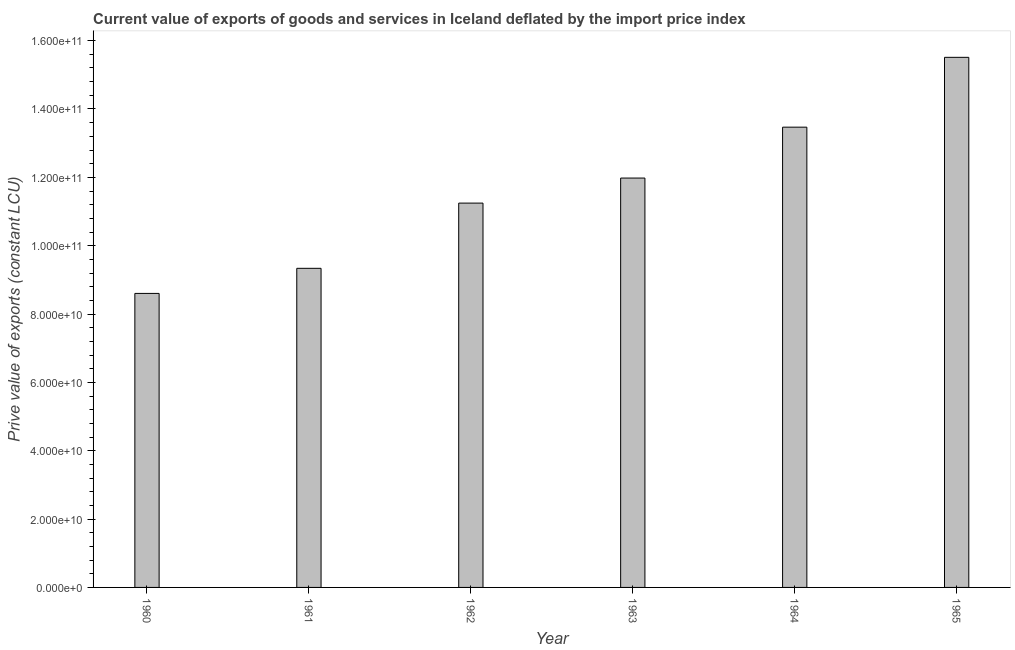What is the title of the graph?
Offer a terse response. Current value of exports of goods and services in Iceland deflated by the import price index. What is the label or title of the Y-axis?
Your answer should be very brief. Prive value of exports (constant LCU). What is the price value of exports in 1962?
Provide a succinct answer. 1.12e+11. Across all years, what is the maximum price value of exports?
Your answer should be very brief. 1.55e+11. Across all years, what is the minimum price value of exports?
Provide a succinct answer. 8.60e+1. In which year was the price value of exports maximum?
Provide a succinct answer. 1965. What is the sum of the price value of exports?
Give a very brief answer. 7.01e+11. What is the difference between the price value of exports in 1963 and 1964?
Keep it short and to the point. -1.49e+1. What is the average price value of exports per year?
Your response must be concise. 1.17e+11. What is the median price value of exports?
Ensure brevity in your answer.  1.16e+11. In how many years, is the price value of exports greater than 148000000000 LCU?
Your answer should be very brief. 1. Do a majority of the years between 1961 and 1963 (inclusive) have price value of exports greater than 72000000000 LCU?
Keep it short and to the point. Yes. What is the ratio of the price value of exports in 1963 to that in 1964?
Provide a succinct answer. 0.89. Is the price value of exports in 1962 less than that in 1964?
Offer a very short reply. Yes. What is the difference between the highest and the second highest price value of exports?
Keep it short and to the point. 2.04e+1. Is the sum of the price value of exports in 1962 and 1964 greater than the maximum price value of exports across all years?
Offer a terse response. Yes. What is the difference between the highest and the lowest price value of exports?
Offer a very short reply. 6.91e+1. What is the Prive value of exports (constant LCU) in 1960?
Offer a terse response. 8.60e+1. What is the Prive value of exports (constant LCU) in 1961?
Offer a terse response. 9.34e+1. What is the Prive value of exports (constant LCU) in 1962?
Keep it short and to the point. 1.12e+11. What is the Prive value of exports (constant LCU) in 1963?
Ensure brevity in your answer.  1.20e+11. What is the Prive value of exports (constant LCU) of 1964?
Provide a short and direct response. 1.35e+11. What is the Prive value of exports (constant LCU) in 1965?
Ensure brevity in your answer.  1.55e+11. What is the difference between the Prive value of exports (constant LCU) in 1960 and 1961?
Keep it short and to the point. -7.34e+09. What is the difference between the Prive value of exports (constant LCU) in 1960 and 1962?
Provide a short and direct response. -2.64e+1. What is the difference between the Prive value of exports (constant LCU) in 1960 and 1963?
Your response must be concise. -3.38e+1. What is the difference between the Prive value of exports (constant LCU) in 1960 and 1964?
Make the answer very short. -4.87e+1. What is the difference between the Prive value of exports (constant LCU) in 1960 and 1965?
Your answer should be very brief. -6.91e+1. What is the difference between the Prive value of exports (constant LCU) in 1961 and 1962?
Keep it short and to the point. -1.91e+1. What is the difference between the Prive value of exports (constant LCU) in 1961 and 1963?
Make the answer very short. -2.64e+1. What is the difference between the Prive value of exports (constant LCU) in 1961 and 1964?
Ensure brevity in your answer.  -4.13e+1. What is the difference between the Prive value of exports (constant LCU) in 1961 and 1965?
Your answer should be very brief. -6.17e+1. What is the difference between the Prive value of exports (constant LCU) in 1962 and 1963?
Give a very brief answer. -7.33e+09. What is the difference between the Prive value of exports (constant LCU) in 1962 and 1964?
Your answer should be compact. -2.22e+1. What is the difference between the Prive value of exports (constant LCU) in 1962 and 1965?
Provide a succinct answer. -4.27e+1. What is the difference between the Prive value of exports (constant LCU) in 1963 and 1964?
Provide a short and direct response. -1.49e+1. What is the difference between the Prive value of exports (constant LCU) in 1963 and 1965?
Your answer should be very brief. -3.53e+1. What is the difference between the Prive value of exports (constant LCU) in 1964 and 1965?
Make the answer very short. -2.04e+1. What is the ratio of the Prive value of exports (constant LCU) in 1960 to that in 1961?
Offer a terse response. 0.92. What is the ratio of the Prive value of exports (constant LCU) in 1960 to that in 1962?
Ensure brevity in your answer.  0.77. What is the ratio of the Prive value of exports (constant LCU) in 1960 to that in 1963?
Your answer should be compact. 0.72. What is the ratio of the Prive value of exports (constant LCU) in 1960 to that in 1964?
Keep it short and to the point. 0.64. What is the ratio of the Prive value of exports (constant LCU) in 1960 to that in 1965?
Ensure brevity in your answer.  0.56. What is the ratio of the Prive value of exports (constant LCU) in 1961 to that in 1962?
Your answer should be very brief. 0.83. What is the ratio of the Prive value of exports (constant LCU) in 1961 to that in 1963?
Give a very brief answer. 0.78. What is the ratio of the Prive value of exports (constant LCU) in 1961 to that in 1964?
Provide a succinct answer. 0.69. What is the ratio of the Prive value of exports (constant LCU) in 1961 to that in 1965?
Provide a short and direct response. 0.6. What is the ratio of the Prive value of exports (constant LCU) in 1962 to that in 1963?
Provide a short and direct response. 0.94. What is the ratio of the Prive value of exports (constant LCU) in 1962 to that in 1964?
Your response must be concise. 0.83. What is the ratio of the Prive value of exports (constant LCU) in 1962 to that in 1965?
Your response must be concise. 0.72. What is the ratio of the Prive value of exports (constant LCU) in 1963 to that in 1964?
Your answer should be compact. 0.89. What is the ratio of the Prive value of exports (constant LCU) in 1963 to that in 1965?
Offer a very short reply. 0.77. What is the ratio of the Prive value of exports (constant LCU) in 1964 to that in 1965?
Provide a short and direct response. 0.87. 